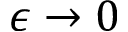Convert formula to latex. <formula><loc_0><loc_0><loc_500><loc_500>\epsilon \to 0</formula> 